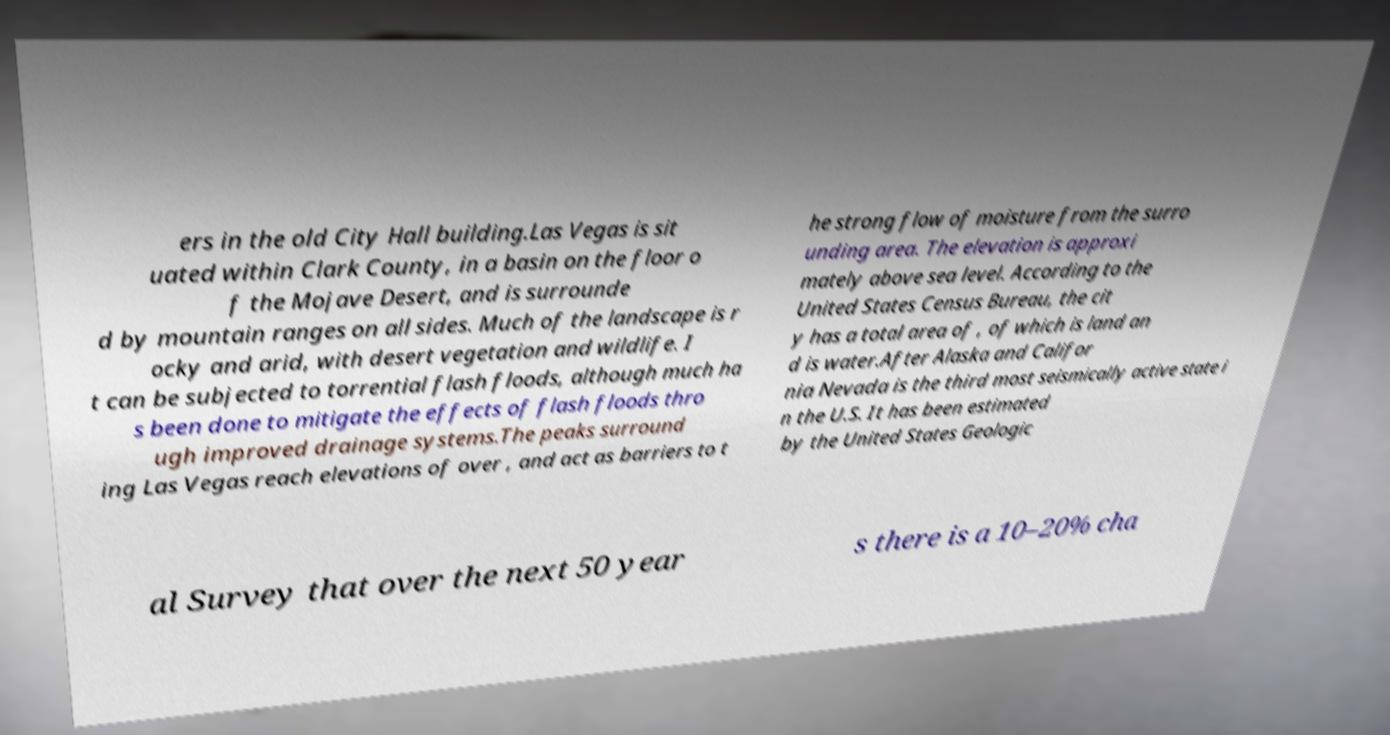What messages or text are displayed in this image? I need them in a readable, typed format. ers in the old City Hall building.Las Vegas is sit uated within Clark County, in a basin on the floor o f the Mojave Desert, and is surrounde d by mountain ranges on all sides. Much of the landscape is r ocky and arid, with desert vegetation and wildlife. I t can be subjected to torrential flash floods, although much ha s been done to mitigate the effects of flash floods thro ugh improved drainage systems.The peaks surround ing Las Vegas reach elevations of over , and act as barriers to t he strong flow of moisture from the surro unding area. The elevation is approxi mately above sea level. According to the United States Census Bureau, the cit y has a total area of , of which is land an d is water.After Alaska and Califor nia Nevada is the third most seismically active state i n the U.S. It has been estimated by the United States Geologic al Survey that over the next 50 year s there is a 10–20% cha 